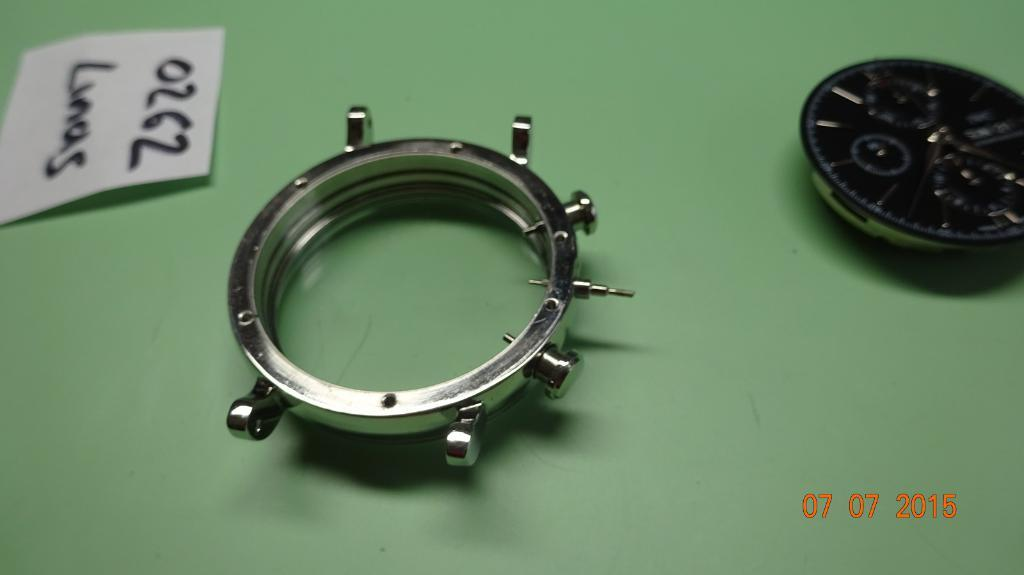<image>
Create a compact narrative representing the image presented. Some parts for the construction of a watch were photographed on 07/07/2015. 